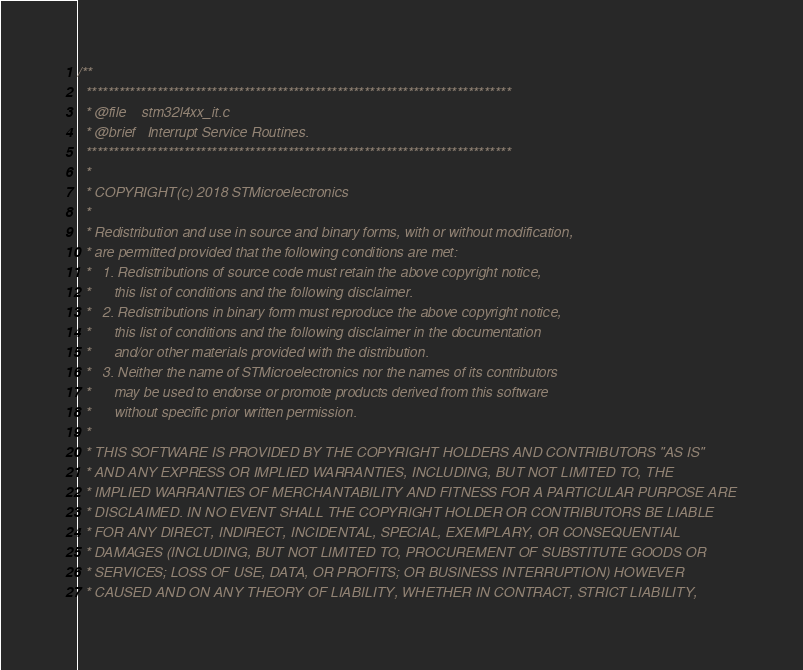<code> <loc_0><loc_0><loc_500><loc_500><_C_>/**
  ******************************************************************************
  * @file    stm32l4xx_it.c
  * @brief   Interrupt Service Routines.
  ******************************************************************************
  *
  * COPYRIGHT(c) 2018 STMicroelectronics
  *
  * Redistribution and use in source and binary forms, with or without modification,
  * are permitted provided that the following conditions are met:
  *   1. Redistributions of source code must retain the above copyright notice,
  *      this list of conditions and the following disclaimer.
  *   2. Redistributions in binary form must reproduce the above copyright notice,
  *      this list of conditions and the following disclaimer in the documentation
  *      and/or other materials provided with the distribution.
  *   3. Neither the name of STMicroelectronics nor the names of its contributors
  *      may be used to endorse or promote products derived from this software
  *      without specific prior written permission.
  *
  * THIS SOFTWARE IS PROVIDED BY THE COPYRIGHT HOLDERS AND CONTRIBUTORS "AS IS"
  * AND ANY EXPRESS OR IMPLIED WARRANTIES, INCLUDING, BUT NOT LIMITED TO, THE
  * IMPLIED WARRANTIES OF MERCHANTABILITY AND FITNESS FOR A PARTICULAR PURPOSE ARE
  * DISCLAIMED. IN NO EVENT SHALL THE COPYRIGHT HOLDER OR CONTRIBUTORS BE LIABLE
  * FOR ANY DIRECT, INDIRECT, INCIDENTAL, SPECIAL, EXEMPLARY, OR CONSEQUENTIAL
  * DAMAGES (INCLUDING, BUT NOT LIMITED TO, PROCUREMENT OF SUBSTITUTE GOODS OR
  * SERVICES; LOSS OF USE, DATA, OR PROFITS; OR BUSINESS INTERRUPTION) HOWEVER
  * CAUSED AND ON ANY THEORY OF LIABILITY, WHETHER IN CONTRACT, STRICT LIABILITY,</code> 